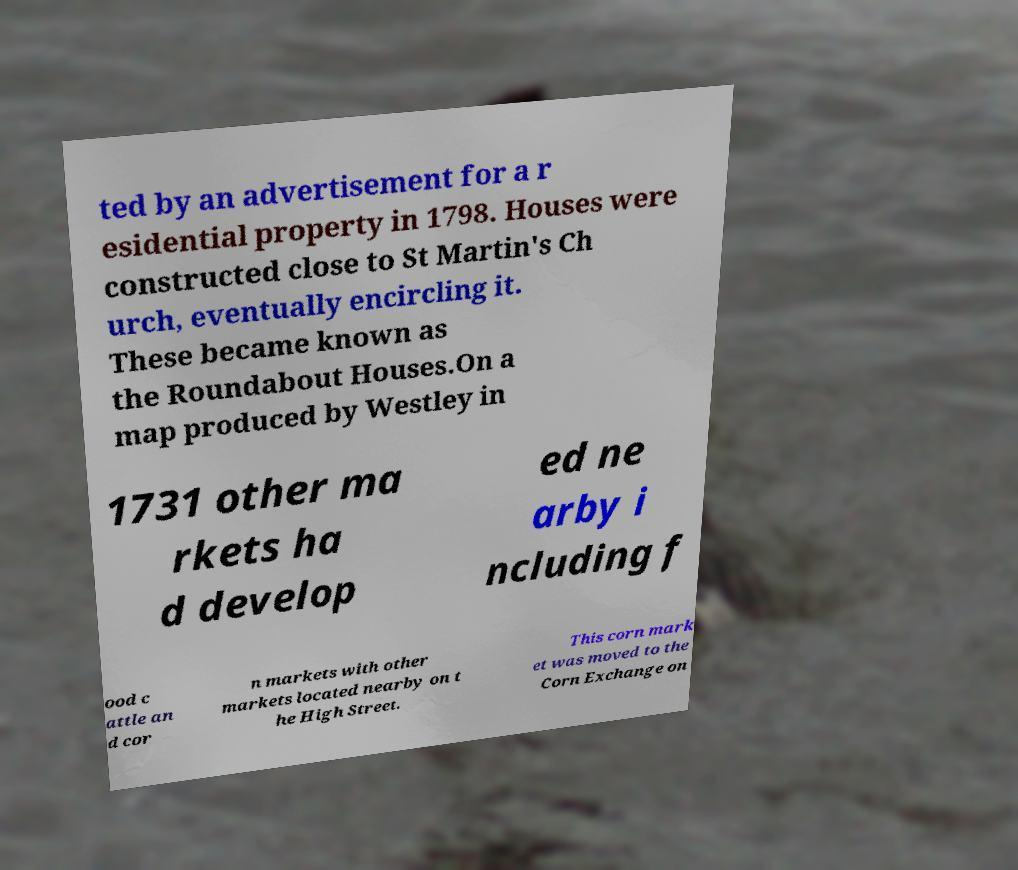I need the written content from this picture converted into text. Can you do that? ted by an advertisement for a r esidential property in 1798. Houses were constructed close to St Martin's Ch urch, eventually encircling it. These became known as the Roundabout Houses.On a map produced by Westley in 1731 other ma rkets ha d develop ed ne arby i ncluding f ood c attle an d cor n markets with other markets located nearby on t he High Street. This corn mark et was moved to the Corn Exchange on 